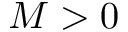<formula> <loc_0><loc_0><loc_500><loc_500>M > 0</formula> 